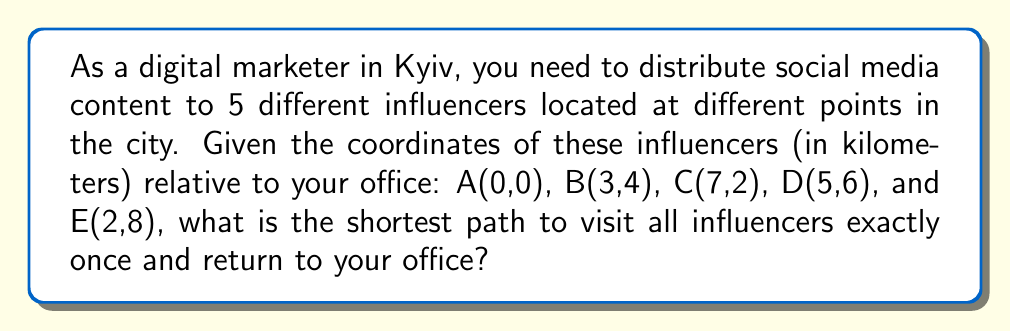Help me with this question. This problem is an application of the Traveling Salesman Problem (TSP) in geometry. To solve it, we'll use the following steps:

1. Calculate distances between all points using the distance formula:
   $$d = \sqrt{(x_2-x_1)^2 + (y_2-y_1)^2}$$

2. Create a distance matrix:
   $$\begin{bmatrix}
   0 & 5 & 7.28 & 7.81 & 8.25 \\
   5 & 0 & 4.47 & 3.61 & 4.12 \\
   7.28 & 4.47 & 0 & 4.47 & 7.21 \\
   7.81 & 3.61 & 4.47 & 0 & 3.61 \\
   8.25 & 4.12 & 7.21 & 3.61 & 0
   \end{bmatrix}$$

3. For a small number of points like this, we can use the brute-force method to find the shortest path. There are $(5-1)! = 24$ possible routes.

4. Calculate the total distance for each route and find the minimum:

   A-B-C-D-E-A: 28.16 km
   A-B-C-E-D-A: 31.77 km
   A-B-D-C-E-A: 28.16 km
   A-B-D-E-C-A: 29.60 km
   A-B-E-C-D-A: 31.77 km
   A-B-E-D-C-A: 29.60 km
   ...

5. The shortest path is A-B-D-C-E-A or A-E-C-D-B-A, both with a total distance of 28.16 km.

[asy]
unitsize(1cm);
dot((0,0)); label("A(0,0)", (0,0), SW);
dot((3,4)); label("B(3,4)", (3,4), SE);
dot((7,2)); label("C(7,2)", (7,2), E);
dot((5,6)); label("D(5,6)", (5,6), NE);
dot((2,8)); label("E(2,8)", (2,8), N);
draw((0,0)--(3,4)--(5,6)--(7,2)--(2,8)--cycle, arrow=Arrow(TeXHead));
[/asy]
Answer: A-B-D-C-E-A or A-E-C-D-B-A, 28.16 km 